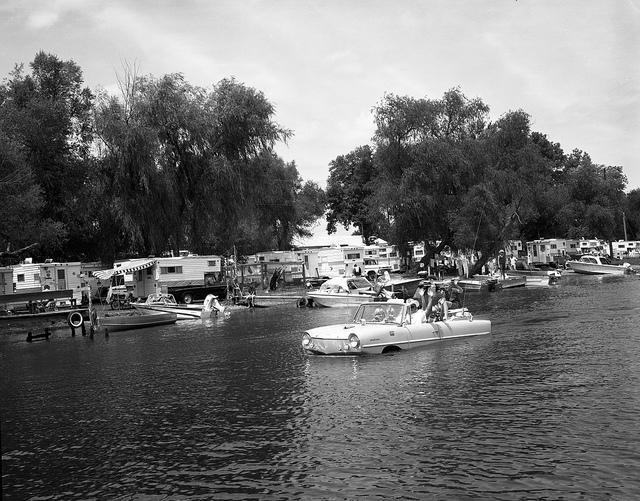What is sticking up out of the water?
Answer briefly. Car. Is the water clear?
Give a very brief answer. Yes. How many boats are there if you skip count of one of them?
Be succinct. 4. How old is this photo?
Quick response, please. 50 years. Where are the campers located?
Keep it brief. On land. Why is the car in the water?
Write a very short answer. Flood. 